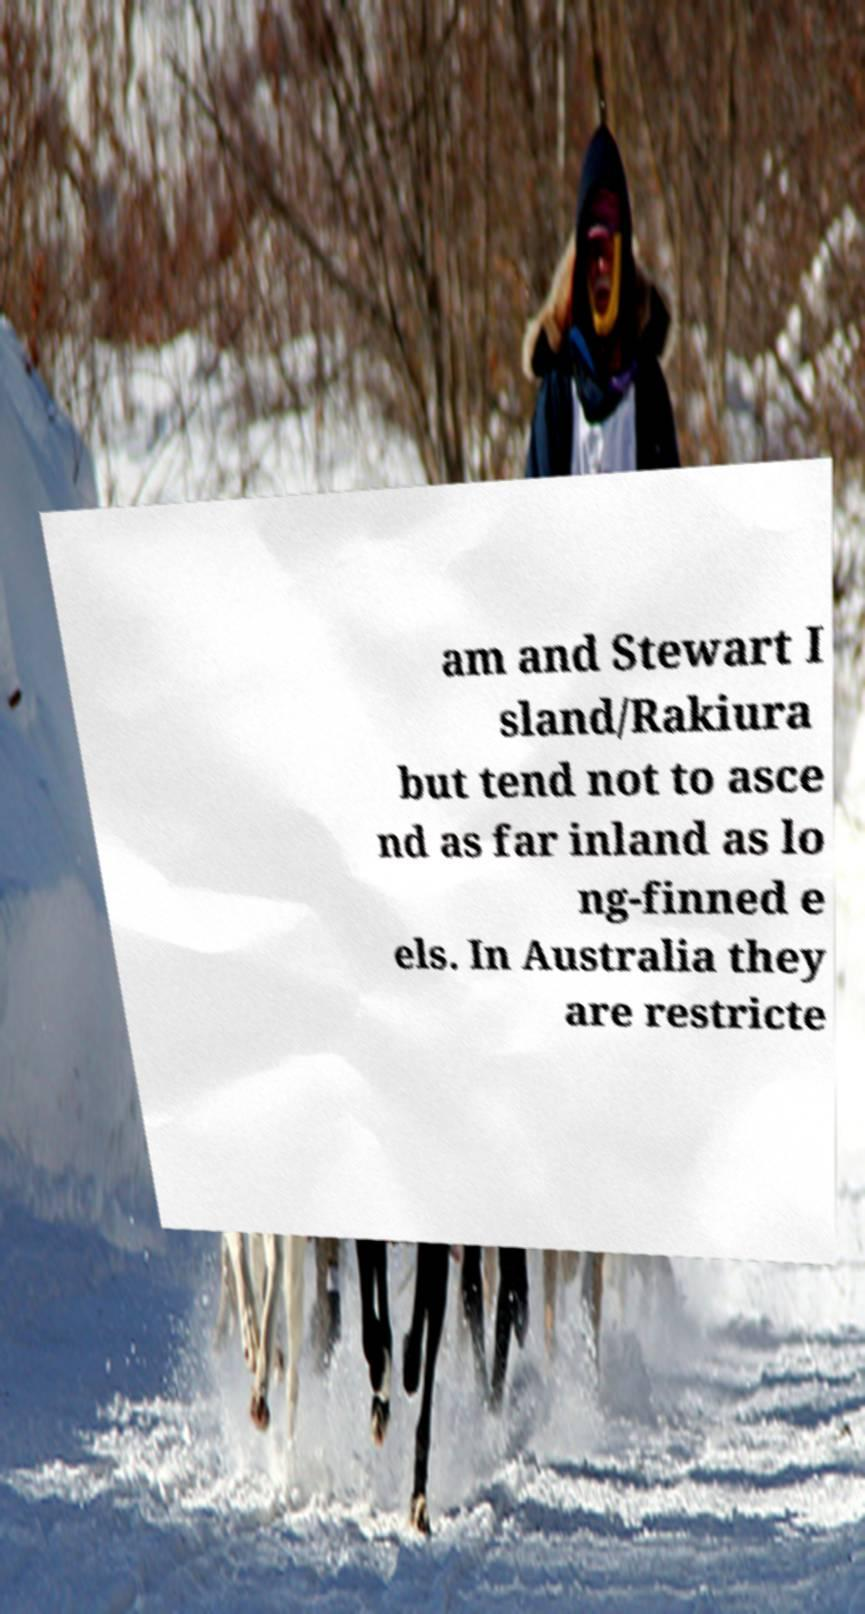Can you accurately transcribe the text from the provided image for me? am and Stewart I sland/Rakiura but tend not to asce nd as far inland as lo ng-finned e els. In Australia they are restricte 